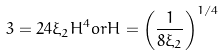<formula> <loc_0><loc_0><loc_500><loc_500>3 = 2 4 \xi _ { 2 } H ^ { 4 } o r H = \left ( \frac { 1 } { 8 \xi _ { 2 } } \right ) ^ { 1 / 4 }</formula> 